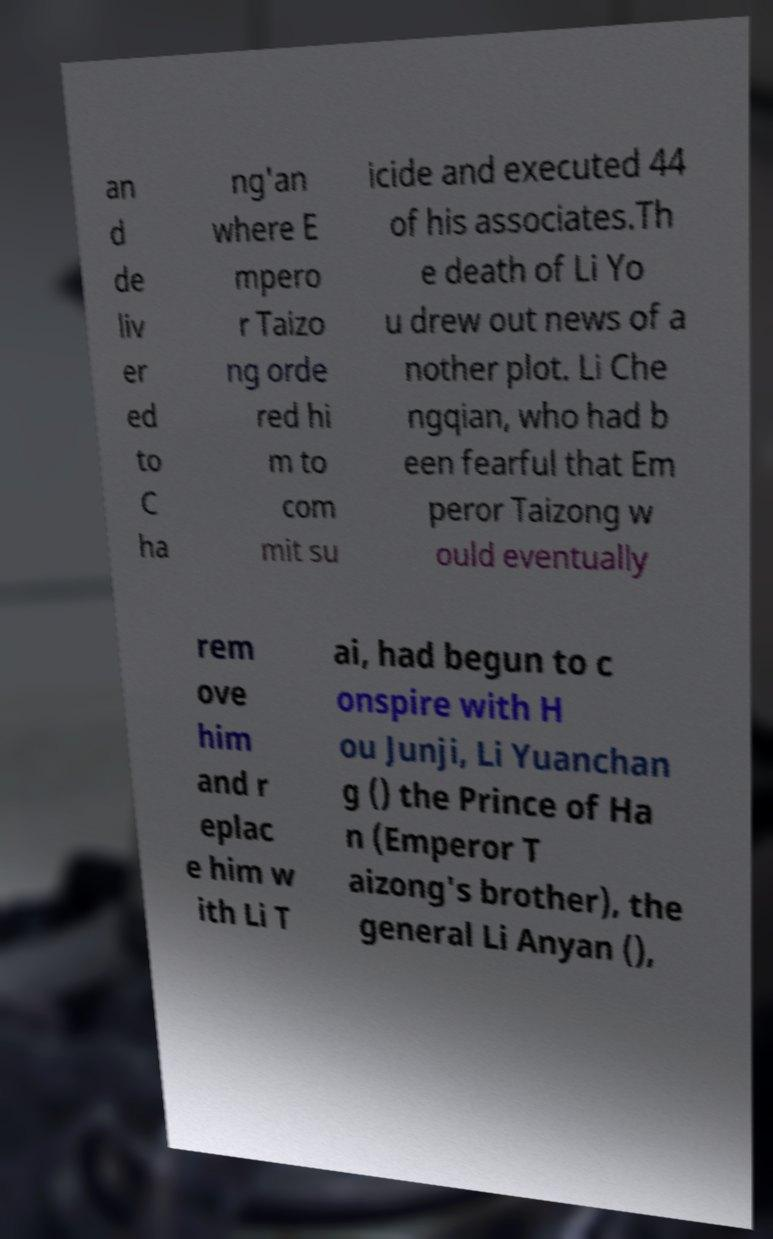I need the written content from this picture converted into text. Can you do that? an d de liv er ed to C ha ng'an where E mpero r Taizo ng orde red hi m to com mit su icide and executed 44 of his associates.Th e death of Li Yo u drew out news of a nother plot. Li Che ngqian, who had b een fearful that Em peror Taizong w ould eventually rem ove him and r eplac e him w ith Li T ai, had begun to c onspire with H ou Junji, Li Yuanchan g () the Prince of Ha n (Emperor T aizong's brother), the general Li Anyan (), 